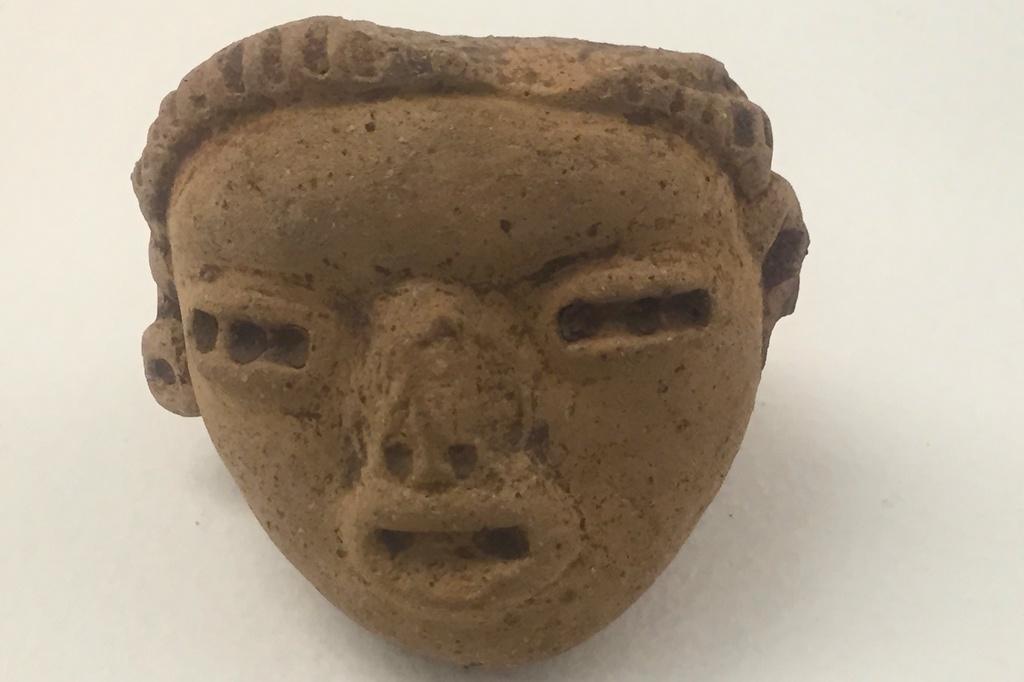Please provide a concise description of this image. In this picture we can see a face sculpture in the front, it looks like a wall in the background. 